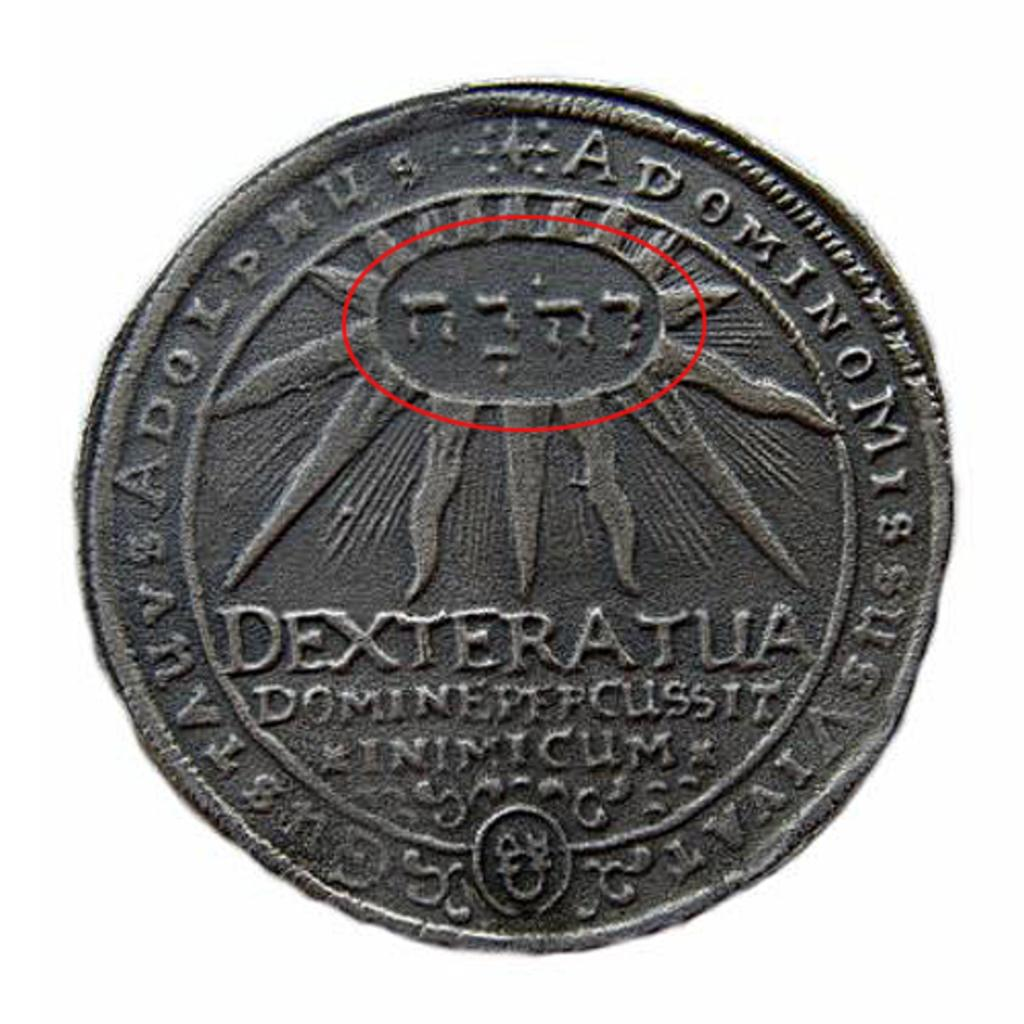<image>
Summarize the visual content of the image. a coin that has the word Dexteratua written on it 